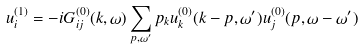<formula> <loc_0><loc_0><loc_500><loc_500>u _ { i } ^ { ( 1 ) } = - i G _ { i j } ^ { ( 0 ) } ( { k } , \omega ) \sum _ { { p } , { \omega } ^ { \prime } } p _ { k } u _ { k } ^ { ( 0 ) } ( { k } - { p } , \omega ^ { \prime } ) u _ { j } ^ { ( 0 ) } ( { p } , \omega - \omega ^ { \prime } )</formula> 